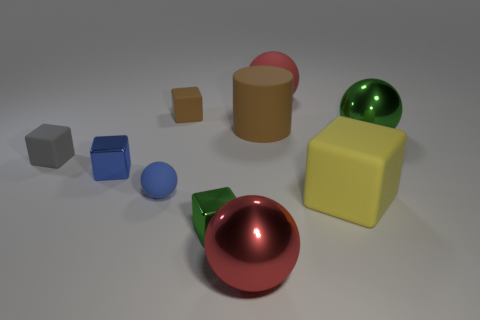There is a tiny blue ball behind the matte cube right of the large rubber thing that is behind the tiny brown rubber thing; what is its material?
Make the answer very short. Rubber. Are there an equal number of red metal balls left of the blue sphere and green matte objects?
Your answer should be compact. Yes. Is the tiny thing behind the large cylinder made of the same material as the object that is left of the small blue cube?
Make the answer very short. Yes. Do the brown object to the left of the large brown rubber cylinder and the gray matte thing in front of the large rubber cylinder have the same shape?
Your answer should be very brief. Yes. Is the number of big yellow things that are right of the green sphere less than the number of green balls?
Give a very brief answer. Yes. What number of large metallic objects have the same color as the big rubber sphere?
Your response must be concise. 1. There is a green shiny thing that is in front of the big matte block; what is its size?
Make the answer very short. Small. There is a matte object on the right side of the matte sphere to the right of the metallic cube that is to the right of the blue metallic thing; what is its shape?
Your response must be concise. Cube. There is a large rubber thing that is behind the gray thing and on the right side of the brown matte cylinder; what is its shape?
Offer a terse response. Sphere. Is there a block that has the same size as the yellow matte object?
Make the answer very short. No. 